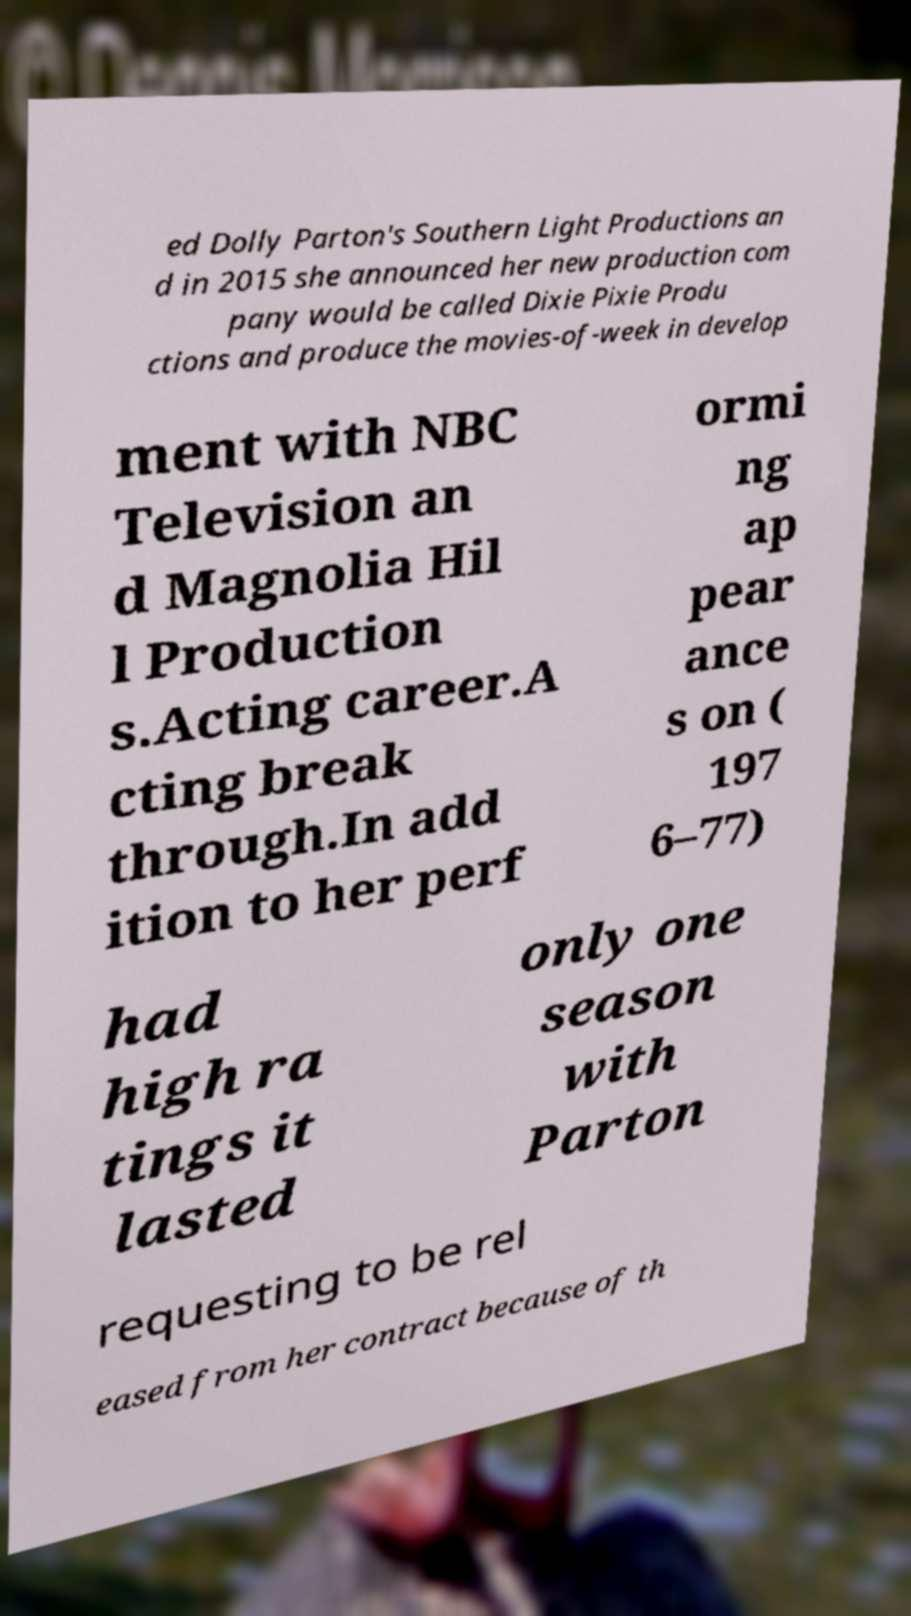What messages or text are displayed in this image? I need them in a readable, typed format. ed Dolly Parton's Southern Light Productions an d in 2015 she announced her new production com pany would be called Dixie Pixie Produ ctions and produce the movies-of-week in develop ment with NBC Television an d Magnolia Hil l Production s.Acting career.A cting break through.In add ition to her perf ormi ng ap pear ance s on ( 197 6–77) had high ra tings it lasted only one season with Parton requesting to be rel eased from her contract because of th 